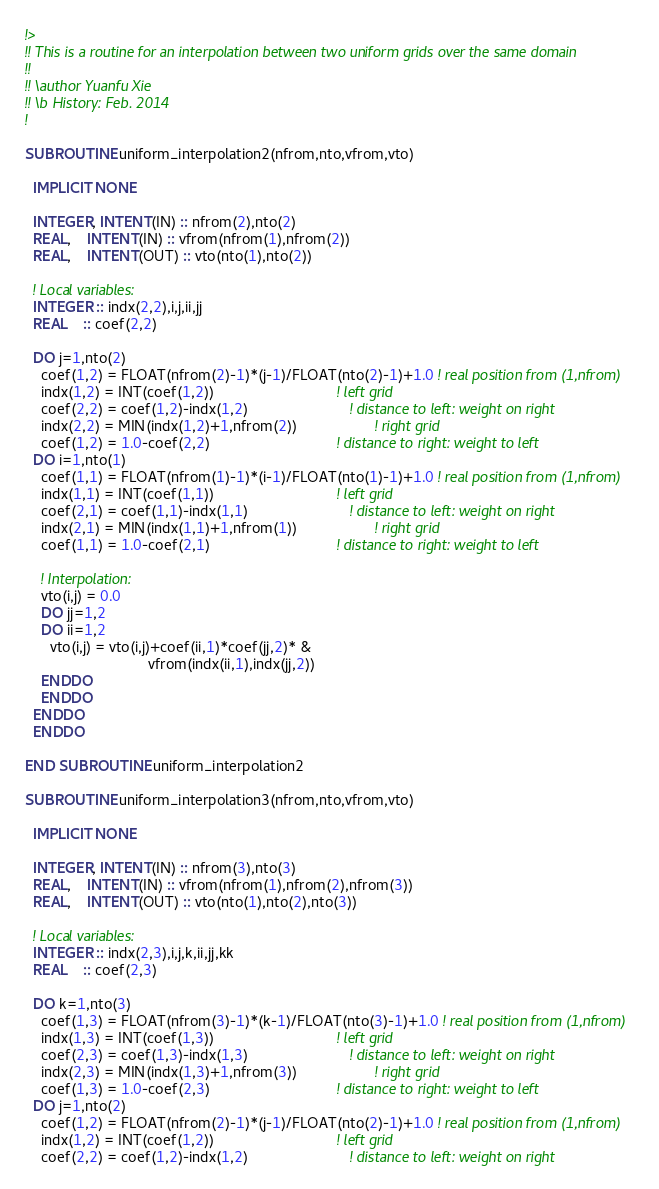<code> <loc_0><loc_0><loc_500><loc_500><_FORTRAN_>!>
!! This is a routine for an interpolation between two uniform grids over the same domain
!!
!! \author Yuanfu Xie
!! \b History: Feb. 2014
!

SUBROUTINE uniform_interpolation2(nfrom,nto,vfrom,vto)

  IMPLICIT NONE

  INTEGER, INTENT(IN) :: nfrom(2),nto(2)
  REAL,    INTENT(IN) :: vfrom(nfrom(1),nfrom(2))
  REAL,    INTENT(OUT) :: vto(nto(1),nto(2))

  ! Local variables:
  INTEGER :: indx(2,2),i,j,ii,jj
  REAL    :: coef(2,2)

  DO j=1,nto(2)
    coef(1,2) = FLOAT(nfrom(2)-1)*(j-1)/FLOAT(nto(2)-1)+1.0 ! real position from (1,nfrom)
    indx(1,2) = INT(coef(1,2))                              ! left grid
    coef(2,2) = coef(1,2)-indx(1,2)                         ! distance to left: weight on right
    indx(2,2) = MIN(indx(1,2)+1,nfrom(2))                   ! right grid
    coef(1,2) = 1.0-coef(2,2)                               ! distance to right: weight to left
  DO i=1,nto(1)
    coef(1,1) = FLOAT(nfrom(1)-1)*(i-1)/FLOAT(nto(1)-1)+1.0 ! real position from (1,nfrom)
    indx(1,1) = INT(coef(1,1))                              ! left grid
    coef(2,1) = coef(1,1)-indx(1,1)                         ! distance to left: weight on right
    indx(2,1) = MIN(indx(1,1)+1,nfrom(1))                   ! right grid
    coef(1,1) = 1.0-coef(2,1)                               ! distance to right: weight to left

    ! Interpolation:
    vto(i,j) = 0.0
    DO jj=1,2
    DO ii=1,2
      vto(i,j) = vto(i,j)+coef(ii,1)*coef(jj,2)* &
                              vfrom(indx(ii,1),indx(jj,2))
    ENDDO
    ENDDO
  ENDDO
  ENDDO

END SUBROUTINE uniform_interpolation2

SUBROUTINE uniform_interpolation3(nfrom,nto,vfrom,vto)

  IMPLICIT NONE

  INTEGER, INTENT(IN) :: nfrom(3),nto(3)
  REAL,    INTENT(IN) :: vfrom(nfrom(1),nfrom(2),nfrom(3))
  REAL,    INTENT(OUT) :: vto(nto(1),nto(2),nto(3))

  ! Local variables:
  INTEGER :: indx(2,3),i,j,k,ii,jj,kk
  REAL    :: coef(2,3)

  DO k=1,nto(3)
    coef(1,3) = FLOAT(nfrom(3)-1)*(k-1)/FLOAT(nto(3)-1)+1.0 ! real position from (1,nfrom)
    indx(1,3) = INT(coef(1,3))                              ! left grid
    coef(2,3) = coef(1,3)-indx(1,3)                         ! distance to left: weight on right
    indx(2,3) = MIN(indx(1,3)+1,nfrom(3))                   ! right grid
    coef(1,3) = 1.0-coef(2,3)                               ! distance to right: weight to left
  DO j=1,nto(2)
    coef(1,2) = FLOAT(nfrom(2)-1)*(j-1)/FLOAT(nto(2)-1)+1.0 ! real position from (1,nfrom)
    indx(1,2) = INT(coef(1,2))                              ! left grid
    coef(2,2) = coef(1,2)-indx(1,2)                         ! distance to left: weight on right</code> 